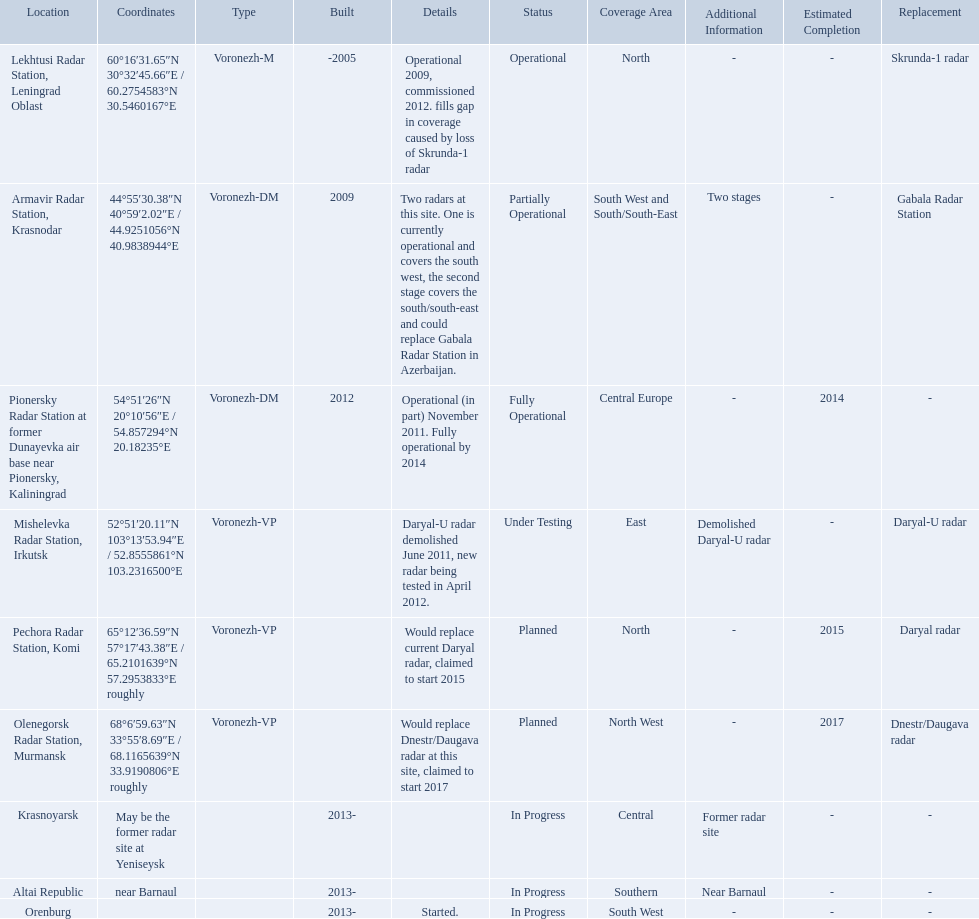What are all of the locations? Lekhtusi Radar Station, Leningrad Oblast, Armavir Radar Station, Krasnodar, Pionersky Radar Station at former Dunayevka air base near Pionersky, Kaliningrad, Mishelevka Radar Station, Irkutsk, Pechora Radar Station, Komi, Olenegorsk Radar Station, Murmansk, Krasnoyarsk, Altai Republic, Orenburg. And which location's coordinates are 60deg16'31.65''n 30deg32'45.66''e / 60.2754583degn 30.5460167dege? Lekhtusi Radar Station, Leningrad Oblast. 